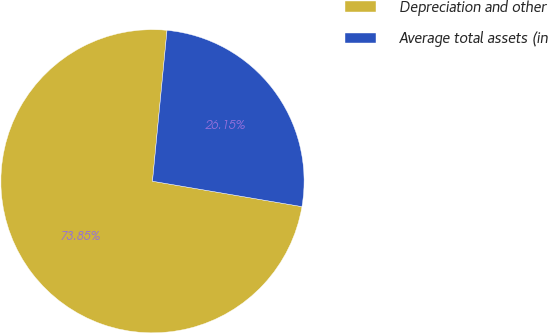Convert chart. <chart><loc_0><loc_0><loc_500><loc_500><pie_chart><fcel>Depreciation and other<fcel>Average total assets (in<nl><fcel>73.85%<fcel>26.15%<nl></chart> 